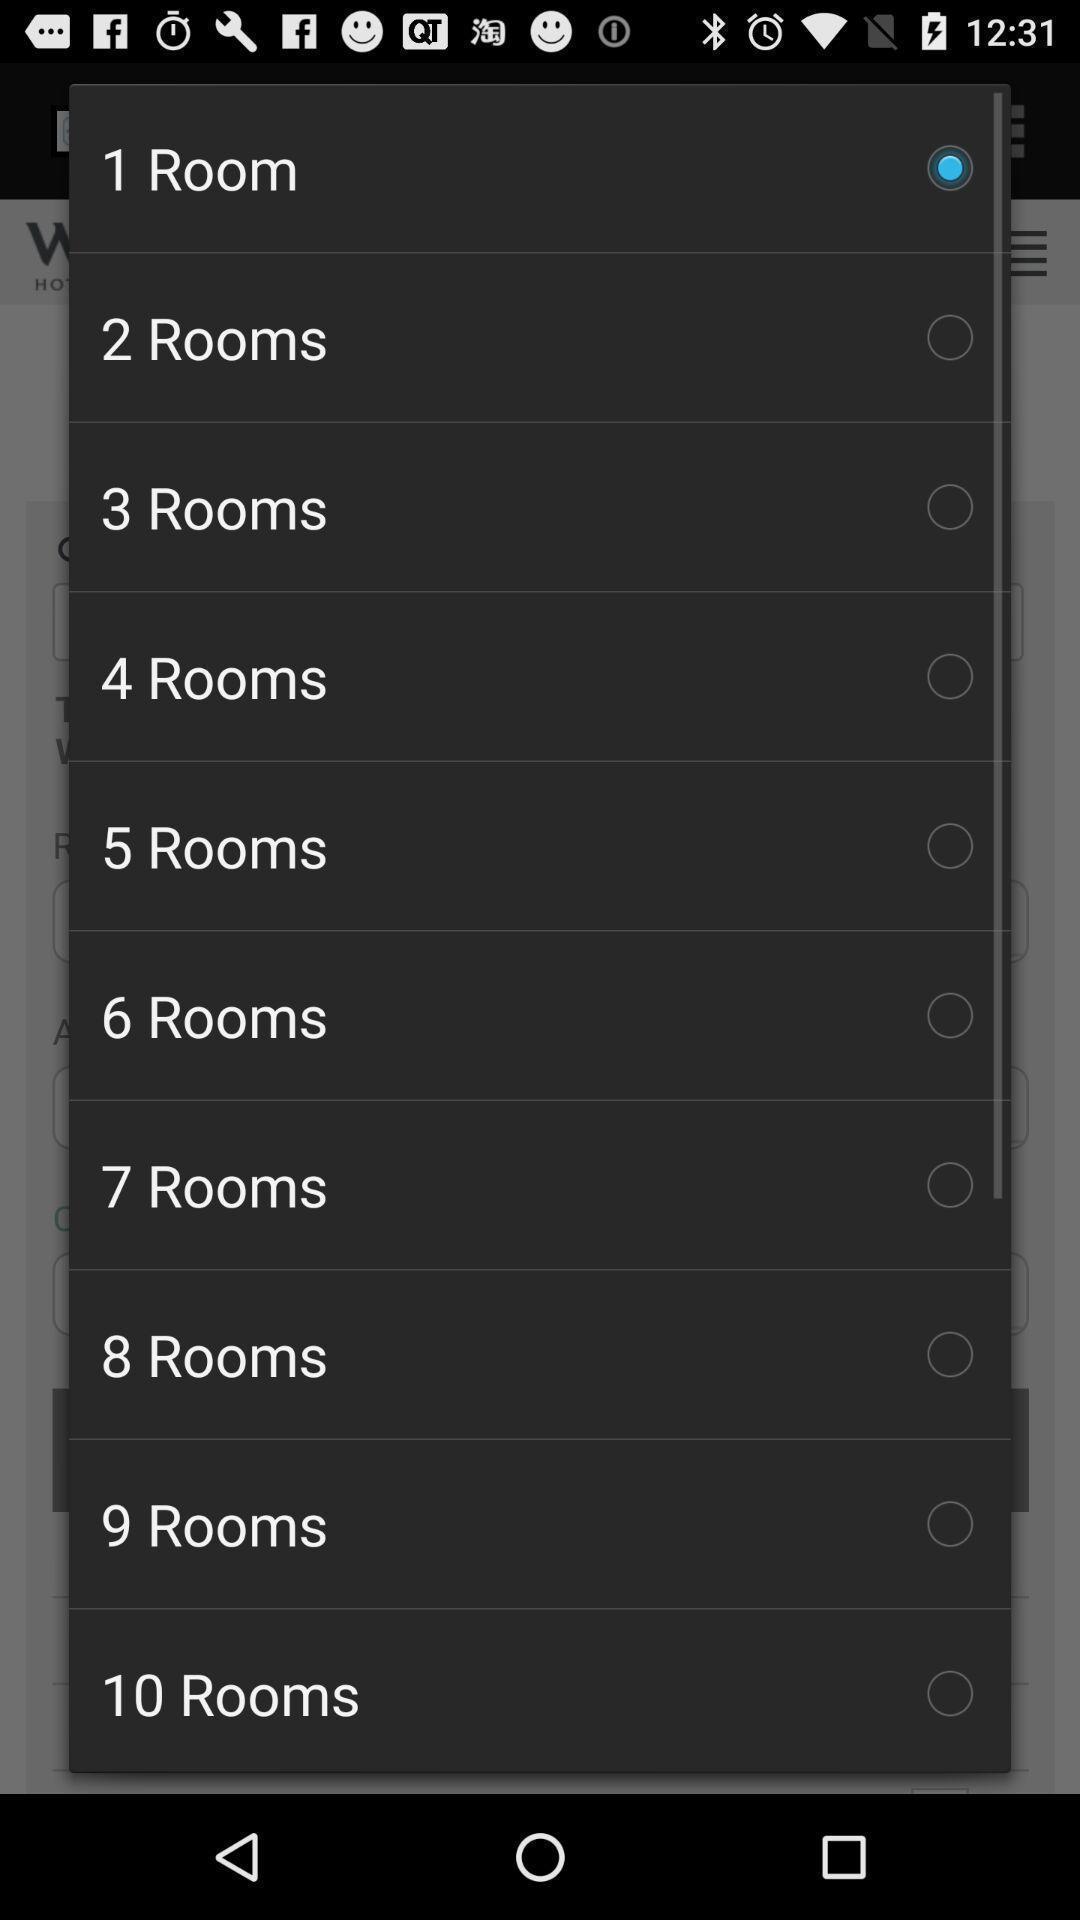What is the overall content of this screenshot? Popup displaying room options to select. 